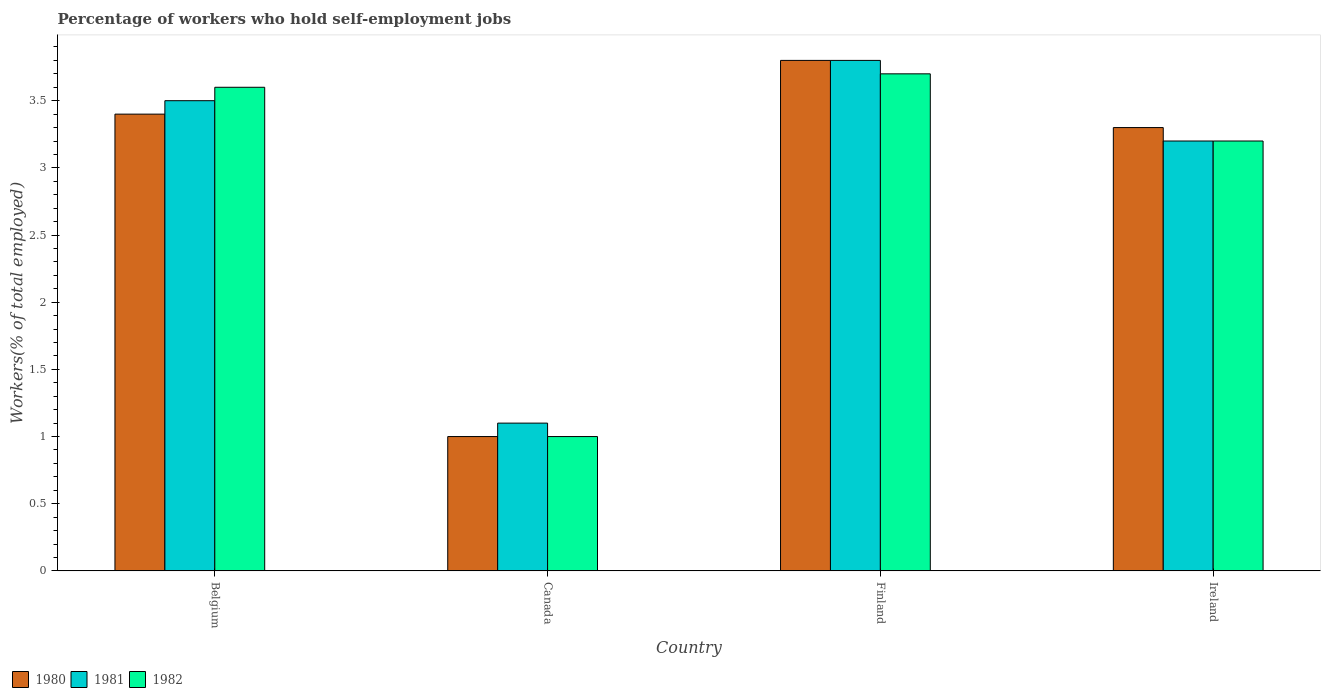How many groups of bars are there?
Give a very brief answer. 4. Are the number of bars per tick equal to the number of legend labels?
Give a very brief answer. Yes. In how many cases, is the number of bars for a given country not equal to the number of legend labels?
Ensure brevity in your answer.  0. What is the percentage of self-employed workers in 1981 in Ireland?
Your response must be concise. 3.2. Across all countries, what is the maximum percentage of self-employed workers in 1981?
Keep it short and to the point. 3.8. In which country was the percentage of self-employed workers in 1982 maximum?
Offer a very short reply. Finland. In which country was the percentage of self-employed workers in 1981 minimum?
Give a very brief answer. Canada. What is the total percentage of self-employed workers in 1981 in the graph?
Ensure brevity in your answer.  11.6. What is the difference between the percentage of self-employed workers in 1981 in Belgium and that in Finland?
Your answer should be very brief. -0.3. What is the difference between the percentage of self-employed workers in 1982 in Belgium and the percentage of self-employed workers in 1981 in Canada?
Your answer should be compact. 2.5. What is the average percentage of self-employed workers in 1982 per country?
Keep it short and to the point. 2.88. In how many countries, is the percentage of self-employed workers in 1980 greater than 3.4 %?
Provide a short and direct response. 2. What is the ratio of the percentage of self-employed workers in 1981 in Belgium to that in Ireland?
Give a very brief answer. 1.09. Is the percentage of self-employed workers in 1981 in Canada less than that in Ireland?
Provide a succinct answer. Yes. What is the difference between the highest and the second highest percentage of self-employed workers in 1982?
Your response must be concise. 0.4. What is the difference between the highest and the lowest percentage of self-employed workers in 1981?
Keep it short and to the point. 2.7. In how many countries, is the percentage of self-employed workers in 1980 greater than the average percentage of self-employed workers in 1980 taken over all countries?
Your answer should be very brief. 3. What does the 3rd bar from the left in Belgium represents?
Give a very brief answer. 1982. Is it the case that in every country, the sum of the percentage of self-employed workers in 1981 and percentage of self-employed workers in 1980 is greater than the percentage of self-employed workers in 1982?
Your answer should be compact. Yes. How many countries are there in the graph?
Keep it short and to the point. 4. Are the values on the major ticks of Y-axis written in scientific E-notation?
Give a very brief answer. No. How many legend labels are there?
Make the answer very short. 3. How are the legend labels stacked?
Offer a terse response. Horizontal. What is the title of the graph?
Your answer should be very brief. Percentage of workers who hold self-employment jobs. Does "1960" appear as one of the legend labels in the graph?
Offer a very short reply. No. What is the label or title of the X-axis?
Your answer should be compact. Country. What is the label or title of the Y-axis?
Your answer should be very brief. Workers(% of total employed). What is the Workers(% of total employed) in 1980 in Belgium?
Your response must be concise. 3.4. What is the Workers(% of total employed) of 1982 in Belgium?
Make the answer very short. 3.6. What is the Workers(% of total employed) in 1981 in Canada?
Ensure brevity in your answer.  1.1. What is the Workers(% of total employed) of 1980 in Finland?
Offer a terse response. 3.8. What is the Workers(% of total employed) in 1981 in Finland?
Keep it short and to the point. 3.8. What is the Workers(% of total employed) in 1982 in Finland?
Offer a terse response. 3.7. What is the Workers(% of total employed) of 1980 in Ireland?
Your response must be concise. 3.3. What is the Workers(% of total employed) of 1981 in Ireland?
Offer a very short reply. 3.2. What is the Workers(% of total employed) in 1982 in Ireland?
Keep it short and to the point. 3.2. Across all countries, what is the maximum Workers(% of total employed) in 1980?
Provide a short and direct response. 3.8. Across all countries, what is the maximum Workers(% of total employed) in 1981?
Ensure brevity in your answer.  3.8. Across all countries, what is the maximum Workers(% of total employed) of 1982?
Give a very brief answer. 3.7. Across all countries, what is the minimum Workers(% of total employed) of 1980?
Offer a very short reply. 1. Across all countries, what is the minimum Workers(% of total employed) in 1981?
Provide a short and direct response. 1.1. Across all countries, what is the minimum Workers(% of total employed) in 1982?
Ensure brevity in your answer.  1. What is the total Workers(% of total employed) of 1982 in the graph?
Offer a very short reply. 11.5. What is the difference between the Workers(% of total employed) in 1982 in Belgium and that in Canada?
Your answer should be very brief. 2.6. What is the difference between the Workers(% of total employed) in 1980 in Belgium and that in Finland?
Give a very brief answer. -0.4. What is the difference between the Workers(% of total employed) of 1981 in Belgium and that in Finland?
Your answer should be very brief. -0.3. What is the difference between the Workers(% of total employed) in 1982 in Belgium and that in Finland?
Offer a terse response. -0.1. What is the difference between the Workers(% of total employed) of 1981 in Belgium and that in Ireland?
Keep it short and to the point. 0.3. What is the difference between the Workers(% of total employed) of 1981 in Canada and that in Finland?
Your response must be concise. -2.7. What is the difference between the Workers(% of total employed) in 1982 in Canada and that in Finland?
Offer a terse response. -2.7. What is the difference between the Workers(% of total employed) in 1980 in Canada and that in Ireland?
Your response must be concise. -2.3. What is the difference between the Workers(% of total employed) of 1981 in Canada and that in Ireland?
Make the answer very short. -2.1. What is the difference between the Workers(% of total employed) in 1980 in Belgium and the Workers(% of total employed) in 1981 in Canada?
Ensure brevity in your answer.  2.3. What is the difference between the Workers(% of total employed) of 1981 in Belgium and the Workers(% of total employed) of 1982 in Finland?
Your response must be concise. -0.2. What is the difference between the Workers(% of total employed) of 1980 in Belgium and the Workers(% of total employed) of 1982 in Ireland?
Provide a succinct answer. 0.2. What is the difference between the Workers(% of total employed) in 1981 in Belgium and the Workers(% of total employed) in 1982 in Ireland?
Give a very brief answer. 0.3. What is the difference between the Workers(% of total employed) in 1980 in Canada and the Workers(% of total employed) in 1982 in Finland?
Give a very brief answer. -2.7. What is the difference between the Workers(% of total employed) in 1980 in Canada and the Workers(% of total employed) in 1981 in Ireland?
Offer a terse response. -2.2. What is the difference between the Workers(% of total employed) of 1980 in Canada and the Workers(% of total employed) of 1982 in Ireland?
Make the answer very short. -2.2. What is the difference between the Workers(% of total employed) in 1981 in Canada and the Workers(% of total employed) in 1982 in Ireland?
Your answer should be compact. -2.1. What is the difference between the Workers(% of total employed) of 1980 in Finland and the Workers(% of total employed) of 1981 in Ireland?
Ensure brevity in your answer.  0.6. What is the difference between the Workers(% of total employed) of 1980 in Finland and the Workers(% of total employed) of 1982 in Ireland?
Provide a succinct answer. 0.6. What is the difference between the Workers(% of total employed) of 1981 in Finland and the Workers(% of total employed) of 1982 in Ireland?
Offer a very short reply. 0.6. What is the average Workers(% of total employed) of 1980 per country?
Your response must be concise. 2.88. What is the average Workers(% of total employed) of 1981 per country?
Offer a terse response. 2.9. What is the average Workers(% of total employed) of 1982 per country?
Provide a short and direct response. 2.88. What is the difference between the Workers(% of total employed) of 1980 and Workers(% of total employed) of 1981 in Belgium?
Provide a succinct answer. -0.1. What is the difference between the Workers(% of total employed) of 1980 and Workers(% of total employed) of 1982 in Belgium?
Provide a short and direct response. -0.2. What is the difference between the Workers(% of total employed) of 1981 and Workers(% of total employed) of 1982 in Belgium?
Ensure brevity in your answer.  -0.1. What is the difference between the Workers(% of total employed) of 1980 and Workers(% of total employed) of 1981 in Canada?
Your answer should be very brief. -0.1. What is the difference between the Workers(% of total employed) of 1981 and Workers(% of total employed) of 1982 in Canada?
Provide a succinct answer. 0.1. What is the difference between the Workers(% of total employed) of 1980 and Workers(% of total employed) of 1981 in Finland?
Provide a succinct answer. 0. What is the difference between the Workers(% of total employed) in 1980 and Workers(% of total employed) in 1982 in Finland?
Your response must be concise. 0.1. What is the difference between the Workers(% of total employed) in 1980 and Workers(% of total employed) in 1981 in Ireland?
Offer a very short reply. 0.1. What is the difference between the Workers(% of total employed) in 1980 and Workers(% of total employed) in 1982 in Ireland?
Ensure brevity in your answer.  0.1. What is the difference between the Workers(% of total employed) of 1981 and Workers(% of total employed) of 1982 in Ireland?
Keep it short and to the point. 0. What is the ratio of the Workers(% of total employed) in 1980 in Belgium to that in Canada?
Ensure brevity in your answer.  3.4. What is the ratio of the Workers(% of total employed) of 1981 in Belgium to that in Canada?
Make the answer very short. 3.18. What is the ratio of the Workers(% of total employed) of 1980 in Belgium to that in Finland?
Offer a very short reply. 0.89. What is the ratio of the Workers(% of total employed) in 1981 in Belgium to that in Finland?
Provide a succinct answer. 0.92. What is the ratio of the Workers(% of total employed) of 1982 in Belgium to that in Finland?
Your answer should be very brief. 0.97. What is the ratio of the Workers(% of total employed) in 1980 in Belgium to that in Ireland?
Offer a terse response. 1.03. What is the ratio of the Workers(% of total employed) of 1981 in Belgium to that in Ireland?
Your answer should be compact. 1.09. What is the ratio of the Workers(% of total employed) in 1980 in Canada to that in Finland?
Give a very brief answer. 0.26. What is the ratio of the Workers(% of total employed) in 1981 in Canada to that in Finland?
Give a very brief answer. 0.29. What is the ratio of the Workers(% of total employed) of 1982 in Canada to that in Finland?
Give a very brief answer. 0.27. What is the ratio of the Workers(% of total employed) in 1980 in Canada to that in Ireland?
Offer a very short reply. 0.3. What is the ratio of the Workers(% of total employed) of 1981 in Canada to that in Ireland?
Offer a very short reply. 0.34. What is the ratio of the Workers(% of total employed) of 1982 in Canada to that in Ireland?
Provide a succinct answer. 0.31. What is the ratio of the Workers(% of total employed) of 1980 in Finland to that in Ireland?
Your response must be concise. 1.15. What is the ratio of the Workers(% of total employed) in 1981 in Finland to that in Ireland?
Make the answer very short. 1.19. What is the ratio of the Workers(% of total employed) in 1982 in Finland to that in Ireland?
Offer a terse response. 1.16. What is the difference between the highest and the second highest Workers(% of total employed) of 1981?
Your answer should be very brief. 0.3. What is the difference between the highest and the lowest Workers(% of total employed) in 1981?
Offer a terse response. 2.7. 